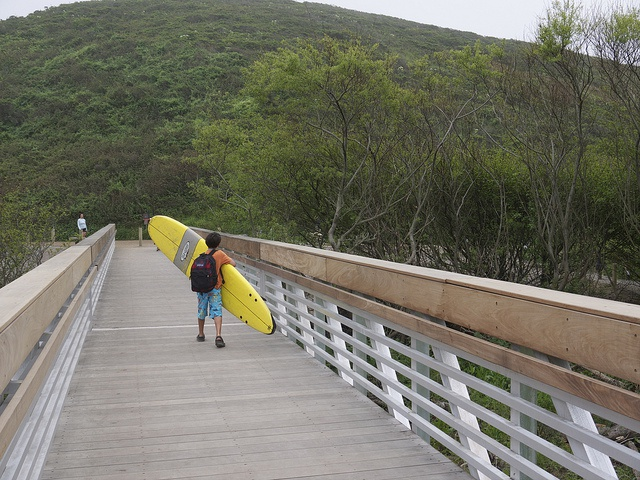Describe the objects in this image and their specific colors. I can see surfboard in lavender, khaki, olive, and gold tones, people in lavender, black, gray, and brown tones, backpack in lavender, black, maroon, and darkgray tones, and people in lavender, black, gray, darkgray, and lightgray tones in this image. 